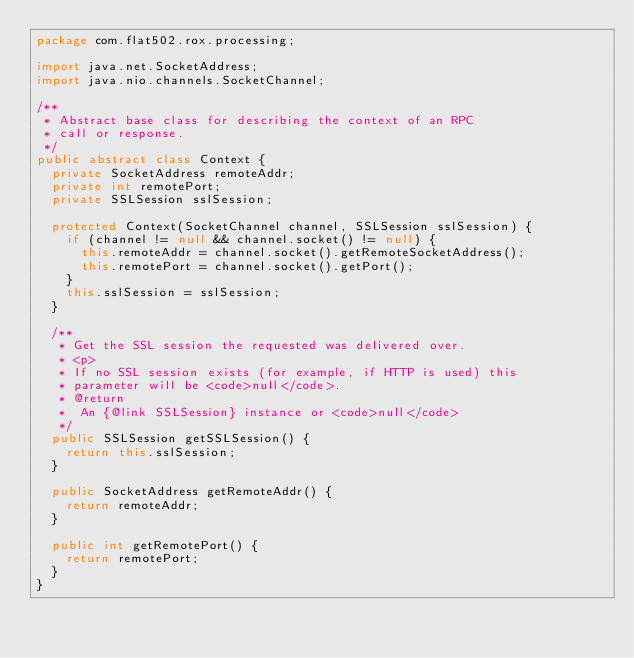<code> <loc_0><loc_0><loc_500><loc_500><_Java_>package com.flat502.rox.processing;

import java.net.SocketAddress;
import java.nio.channels.SocketChannel;

/**
 * Abstract base class for describing the context of an RPC
 * call or response.
 */
public abstract class Context {
	private SocketAddress remoteAddr;
	private int remotePort;
	private SSLSession sslSession;
	
	protected Context(SocketChannel channel, SSLSession sslSession) {
		if (channel != null && channel.socket() != null) {
			this.remoteAddr = channel.socket().getRemoteSocketAddress();
			this.remotePort = channel.socket().getPort();
		}
		this.sslSession = sslSession;
	}

	/**
	 * Get the SSL session the requested was delivered over.
	 * <p>
	 * If no SSL session exists (for example, if HTTP is used) this
	 * parameter will be <code>null</code>.
	 * @return
	 * 	An {@link SSLSession} instance or <code>null</code>
	 */
	public SSLSession getSSLSession() {
		return this.sslSession;
	}

	public SocketAddress getRemoteAddr() {
		return remoteAddr;
	}

	public int getRemotePort() {
		return remotePort;
	}
}
</code> 